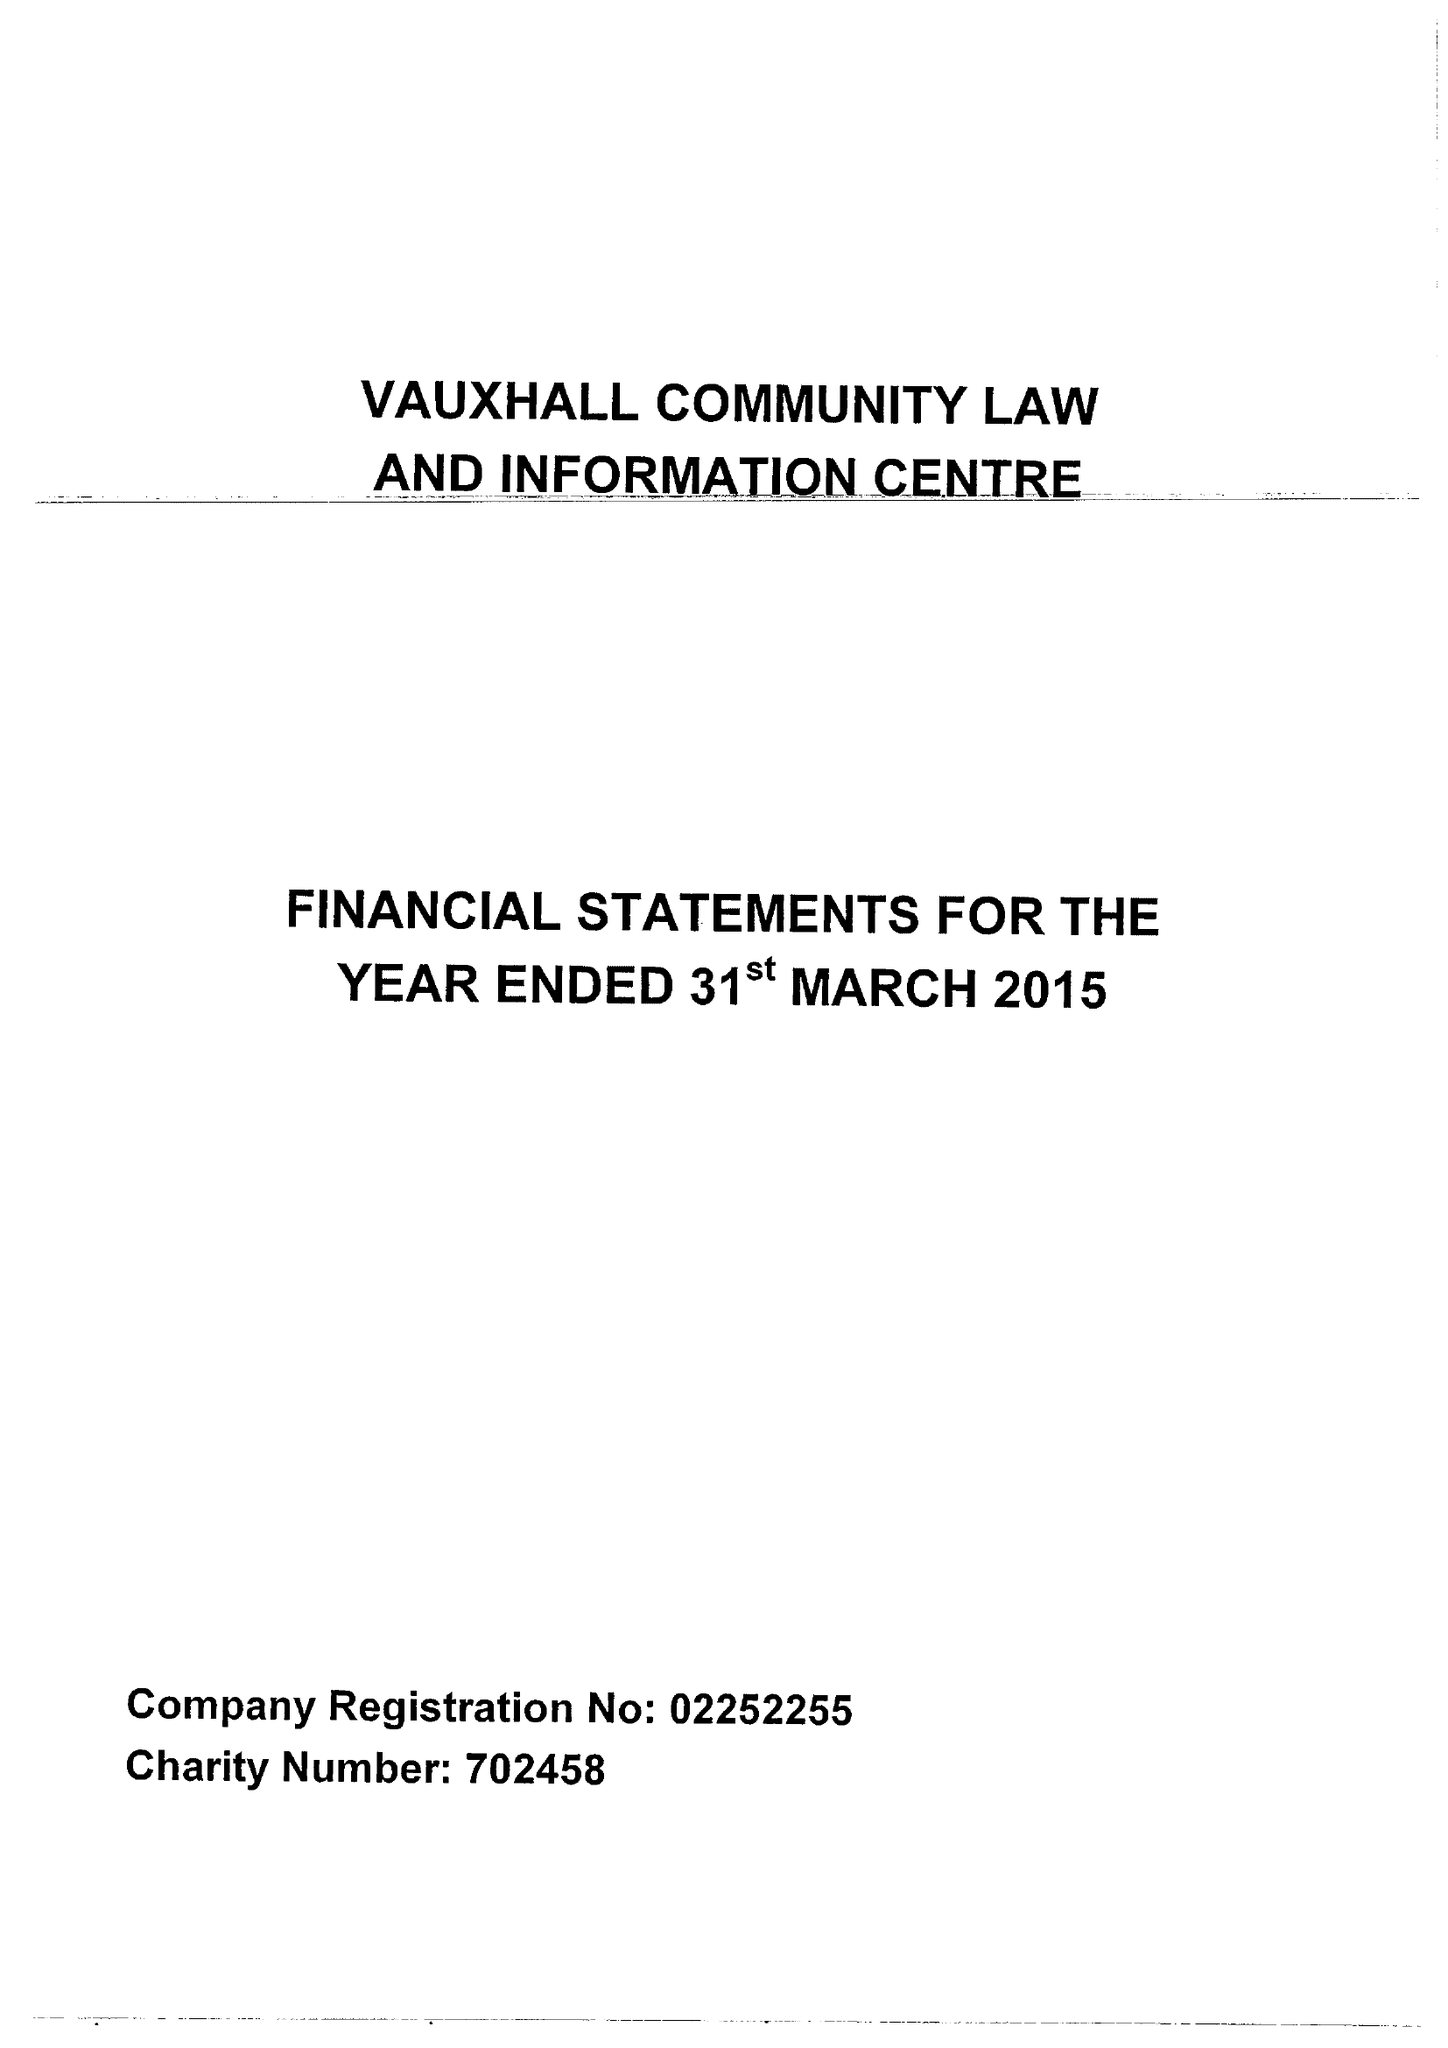What is the value for the charity_name?
Answer the question using a single word or phrase. Vauxhall Community Law and Information Centre 